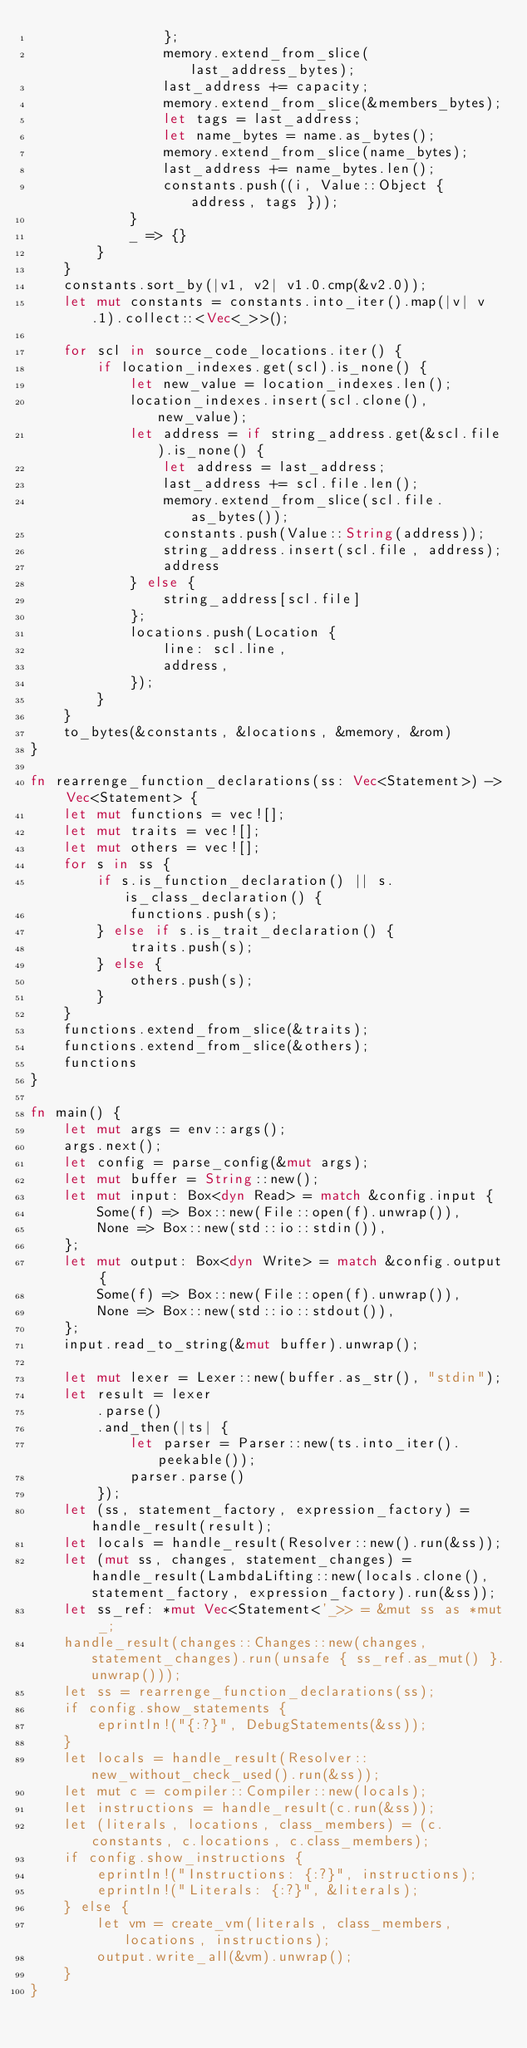<code> <loc_0><loc_0><loc_500><loc_500><_Rust_>                };
                memory.extend_from_slice(last_address_bytes);
                last_address += capacity;
                memory.extend_from_slice(&members_bytes);
                let tags = last_address;
                let name_bytes = name.as_bytes();
                memory.extend_from_slice(name_bytes);
                last_address += name_bytes.len();
                constants.push((i, Value::Object { address, tags }));
            }
            _ => {}
        }
    }
    constants.sort_by(|v1, v2| v1.0.cmp(&v2.0));
    let mut constants = constants.into_iter().map(|v| v.1).collect::<Vec<_>>();

    for scl in source_code_locations.iter() {
        if location_indexes.get(scl).is_none() {
            let new_value = location_indexes.len();
            location_indexes.insert(scl.clone(), new_value);
            let address = if string_address.get(&scl.file).is_none() {
                let address = last_address;
                last_address += scl.file.len();
                memory.extend_from_slice(scl.file.as_bytes());
                constants.push(Value::String(address));
                string_address.insert(scl.file, address);
                address
            } else {
                string_address[scl.file]
            };
            locations.push(Location {
                line: scl.line,
                address,
            });
        }
    }
    to_bytes(&constants, &locations, &memory, &rom)
}

fn rearrenge_function_declarations(ss: Vec<Statement>) -> Vec<Statement> {
    let mut functions = vec![];
    let mut traits = vec![];
    let mut others = vec![];
    for s in ss {
        if s.is_function_declaration() || s.is_class_declaration() {
            functions.push(s);
        } else if s.is_trait_declaration() {
            traits.push(s);
        } else {
            others.push(s);
        }
    }
    functions.extend_from_slice(&traits);
    functions.extend_from_slice(&others);
    functions
}

fn main() {
    let mut args = env::args();
    args.next();
    let config = parse_config(&mut args);
    let mut buffer = String::new();
    let mut input: Box<dyn Read> = match &config.input {
        Some(f) => Box::new(File::open(f).unwrap()),
        None => Box::new(std::io::stdin()),
    };
    let mut output: Box<dyn Write> = match &config.output {
        Some(f) => Box::new(File::open(f).unwrap()),
        None => Box::new(std::io::stdout()),
    };
    input.read_to_string(&mut buffer).unwrap();

    let mut lexer = Lexer::new(buffer.as_str(), "stdin");
    let result = lexer
        .parse()
        .and_then(|ts| {
            let parser = Parser::new(ts.into_iter().peekable());
            parser.parse()
        });
    let (ss, statement_factory, expression_factory) = handle_result(result);
    let locals = handle_result(Resolver::new().run(&ss));
    let (mut ss, changes, statement_changes) = handle_result(LambdaLifting::new(locals.clone(), statement_factory, expression_factory).run(&ss));
    let ss_ref: *mut Vec<Statement<'_>> = &mut ss as *mut _;
    handle_result(changes::Changes::new(changes, statement_changes).run(unsafe { ss_ref.as_mut() }.unwrap()));
    let ss = rearrenge_function_declarations(ss);
    if config.show_statements {
        eprintln!("{:?}", DebugStatements(&ss));
    }
    let locals = handle_result(Resolver::new_without_check_used().run(&ss));
    let mut c = compiler::Compiler::new(locals);
    let instructions = handle_result(c.run(&ss));
    let (literals, locations, class_members) = (c.constants, c.locations, c.class_members);
    if config.show_instructions {
        eprintln!("Instructions: {:?}", instructions);
        eprintln!("Literals: {:?}", &literals);
    } else {
        let vm = create_vm(literals, class_members, locations, instructions);
        output.write_all(&vm).unwrap();
    }
}
</code> 